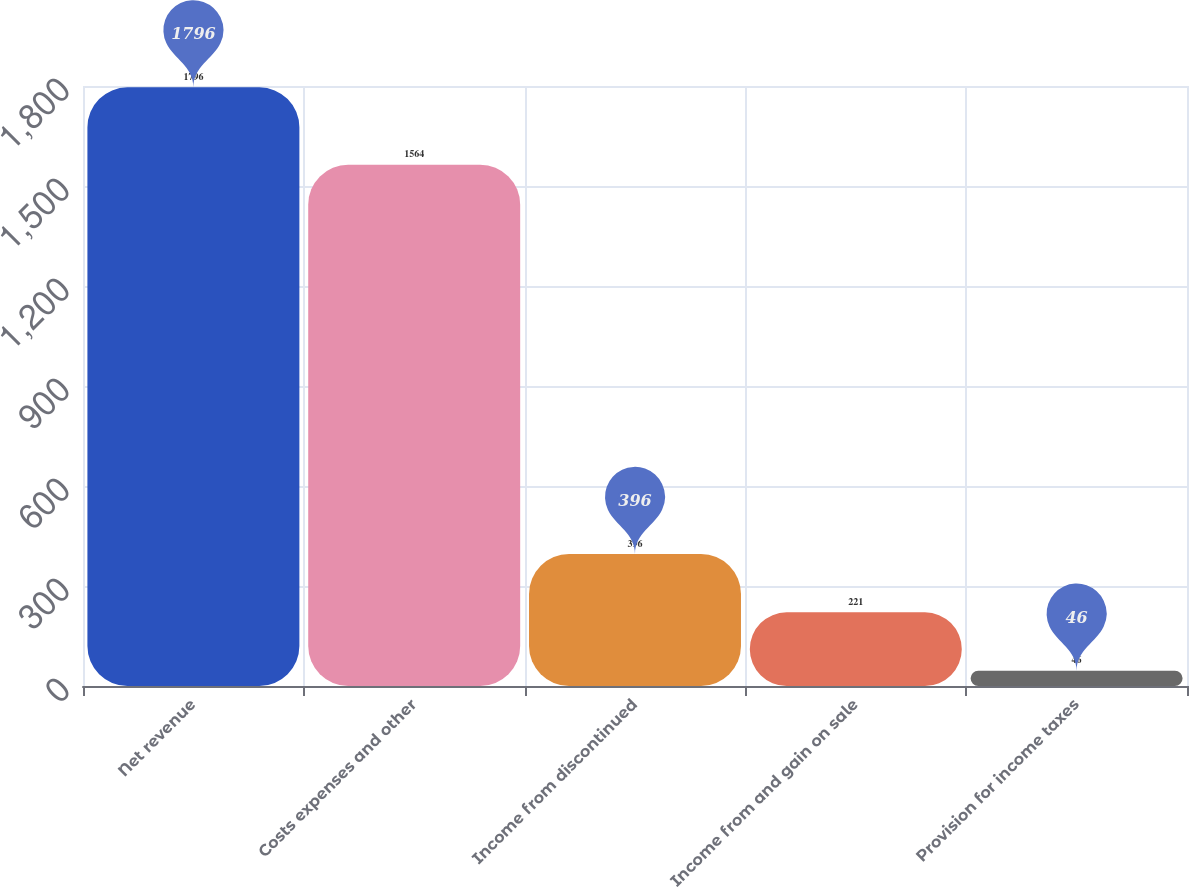<chart> <loc_0><loc_0><loc_500><loc_500><bar_chart><fcel>Net revenue<fcel>Costs expenses and other<fcel>Income from discontinued<fcel>Income from and gain on sale<fcel>Provision for income taxes<nl><fcel>1796<fcel>1564<fcel>396<fcel>221<fcel>46<nl></chart> 